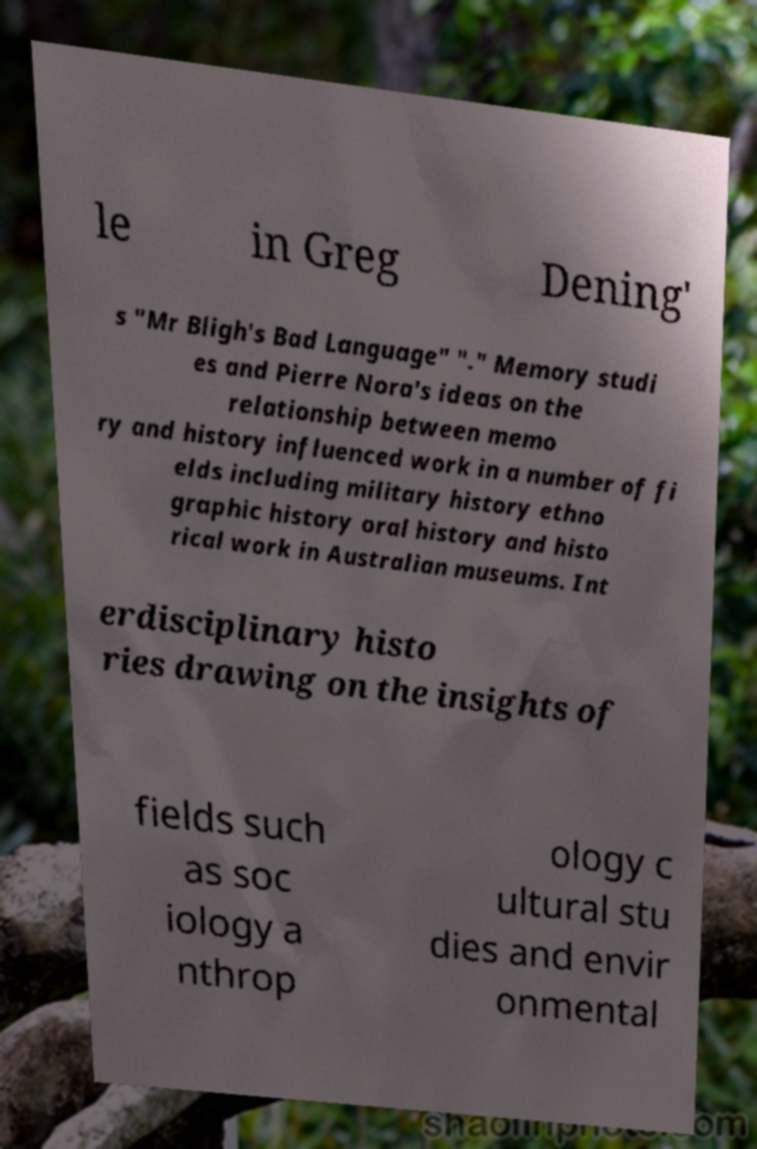Can you accurately transcribe the text from the provided image for me? le in Greg Dening' s "Mr Bligh's Bad Language" "." Memory studi es and Pierre Nora's ideas on the relationship between memo ry and history influenced work in a number of fi elds including military history ethno graphic history oral history and histo rical work in Australian museums. Int erdisciplinary histo ries drawing on the insights of fields such as soc iology a nthrop ology c ultural stu dies and envir onmental 